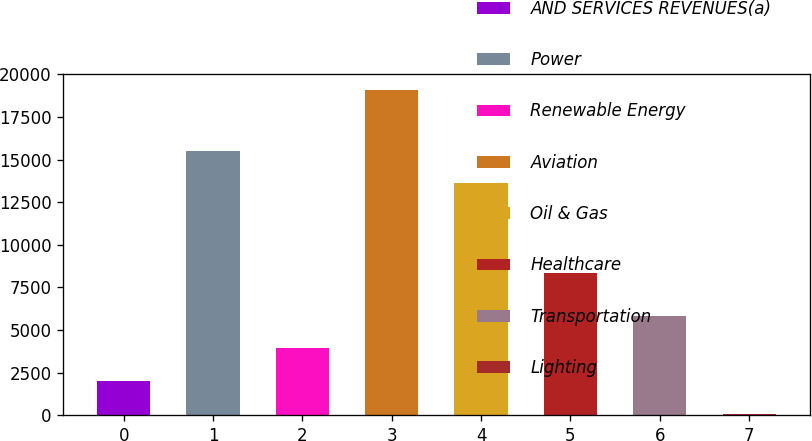Convert chart. <chart><loc_0><loc_0><loc_500><loc_500><bar_chart><fcel>AND SERVICES REVENUES(a)<fcel>Power<fcel>Renewable Energy<fcel>Aviation<fcel>Oil & Gas<fcel>Healthcare<fcel>Transportation<fcel>Lighting<nl><fcel>2018<fcel>15505.4<fcel>3915.4<fcel>19067<fcel>13608<fcel>8363<fcel>5812.8<fcel>93<nl></chart> 